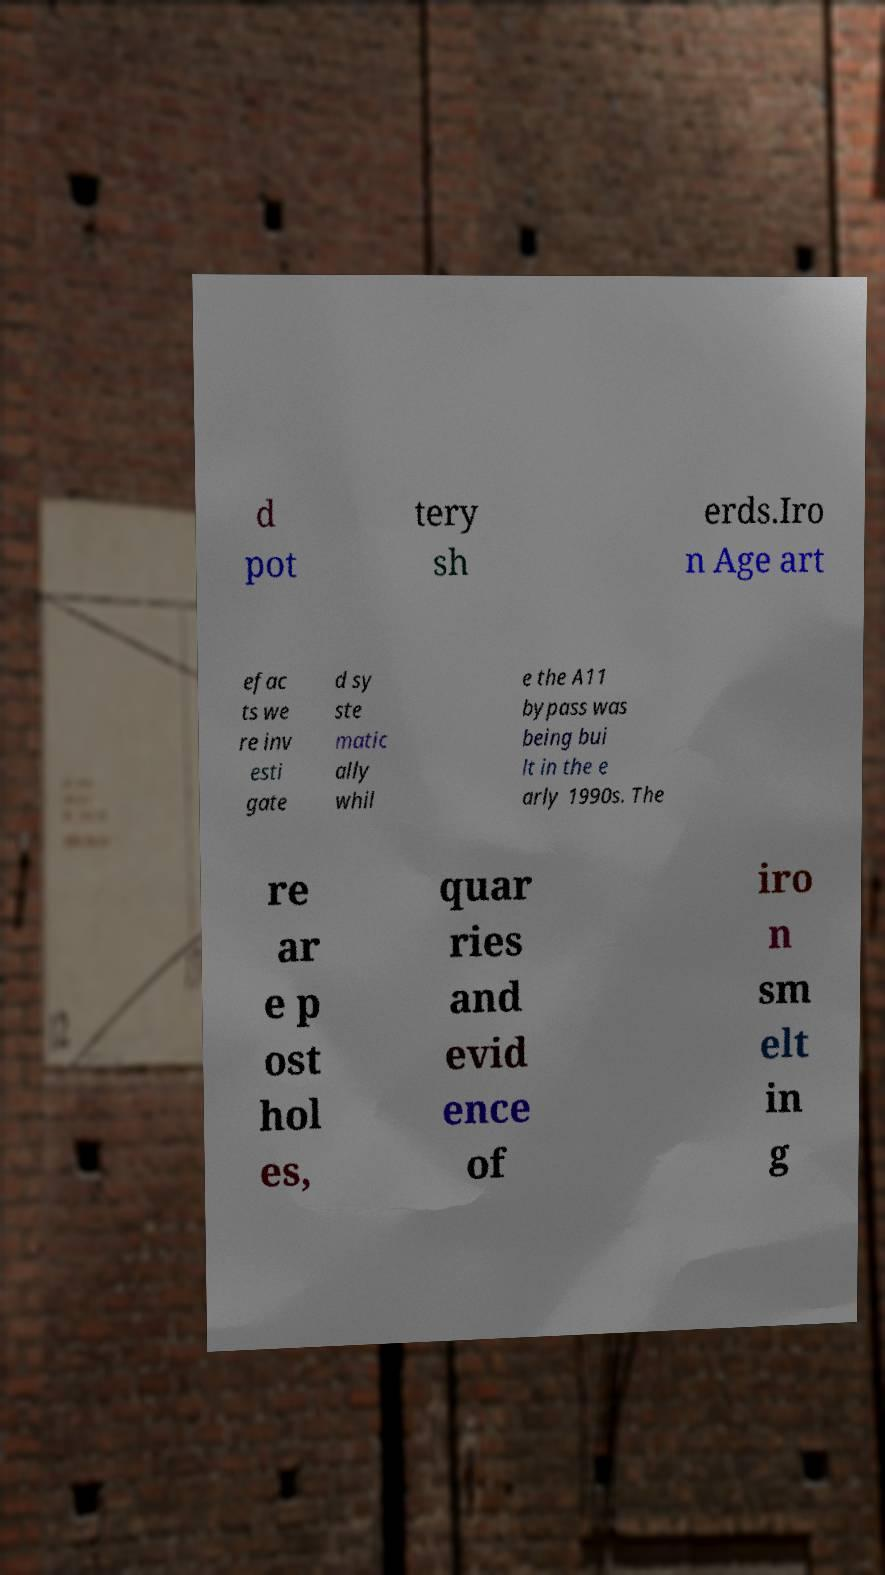For documentation purposes, I need the text within this image transcribed. Could you provide that? d pot tery sh erds.Iro n Age art efac ts we re inv esti gate d sy ste matic ally whil e the A11 bypass was being bui lt in the e arly 1990s. The re ar e p ost hol es, quar ries and evid ence of iro n sm elt in g 